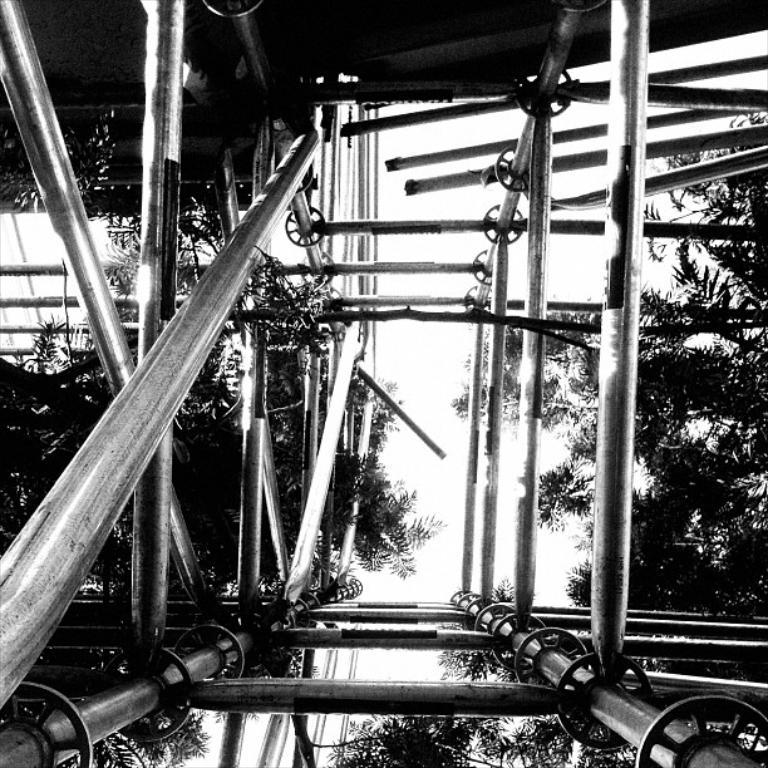What is the color scheme of the image? The image is black and white. What type of objects can be seen in the image? There are metal rods and trees in the image. What part of a building is visible in the image? The roof is visible at the top of the image. Reasoning: Let' Let's think step by step in order to produce the conversation. We start by identifying the color scheme of the image, which is black and white. Then, we describe the main objects in the image, which are metal rods and trees. Finally, we mention the part of a building that is visible, which is the roof. Absurd Question/Answer: How many pieces of meat are hanging from the metal rods in the image? There is no meat present in the image; it only features metal rods and trees. What type of leg is visible in the image? There is no leg visible in the image; it only contains metal rods, trees, and a roof. How many pieces of meat are hanging from the metal rods in the image? There is no meat present in the image; it only features metal rods and trees. What type of leg is visible in the image? There is no leg visible in the image; it only contains metal rods, trees, and a roof. 